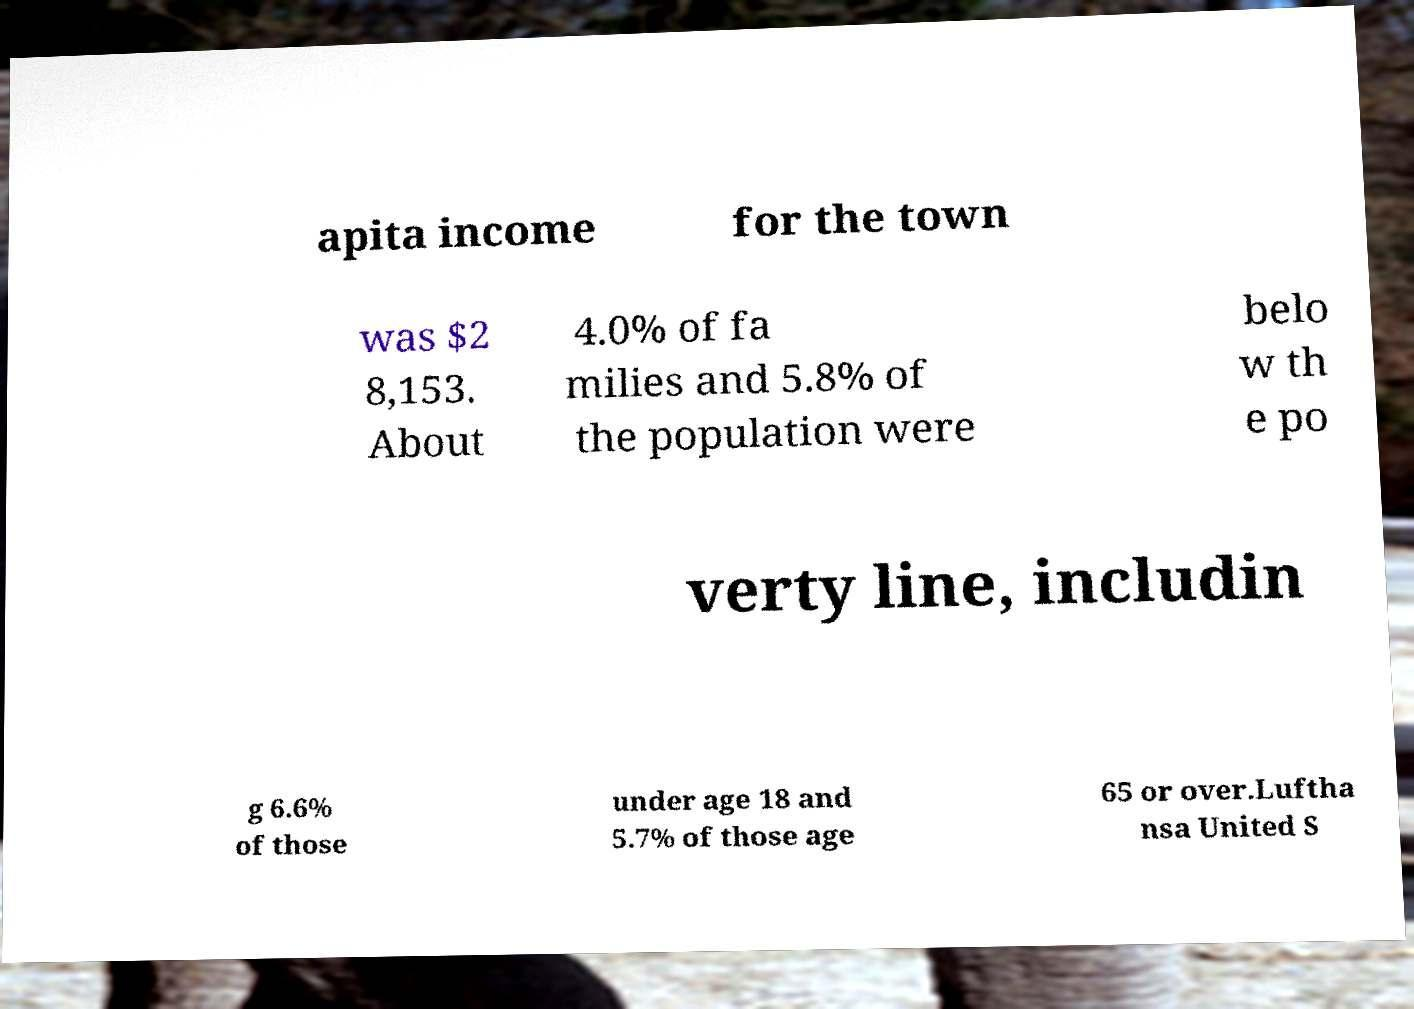For documentation purposes, I need the text within this image transcribed. Could you provide that? apita income for the town was $2 8,153. About 4.0% of fa milies and 5.8% of the population were belo w th e po verty line, includin g 6.6% of those under age 18 and 5.7% of those age 65 or over.Luftha nsa United S 